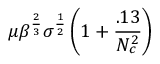Convert formula to latex. <formula><loc_0><loc_0><loc_500><loc_500>\mu \beta ^ { \frac { 2 } { 3 } } \sigma ^ { \frac { 1 } { 2 } } \left ( 1 + \frac { . 1 3 } { N _ { c } ^ { 2 } } \right )</formula> 